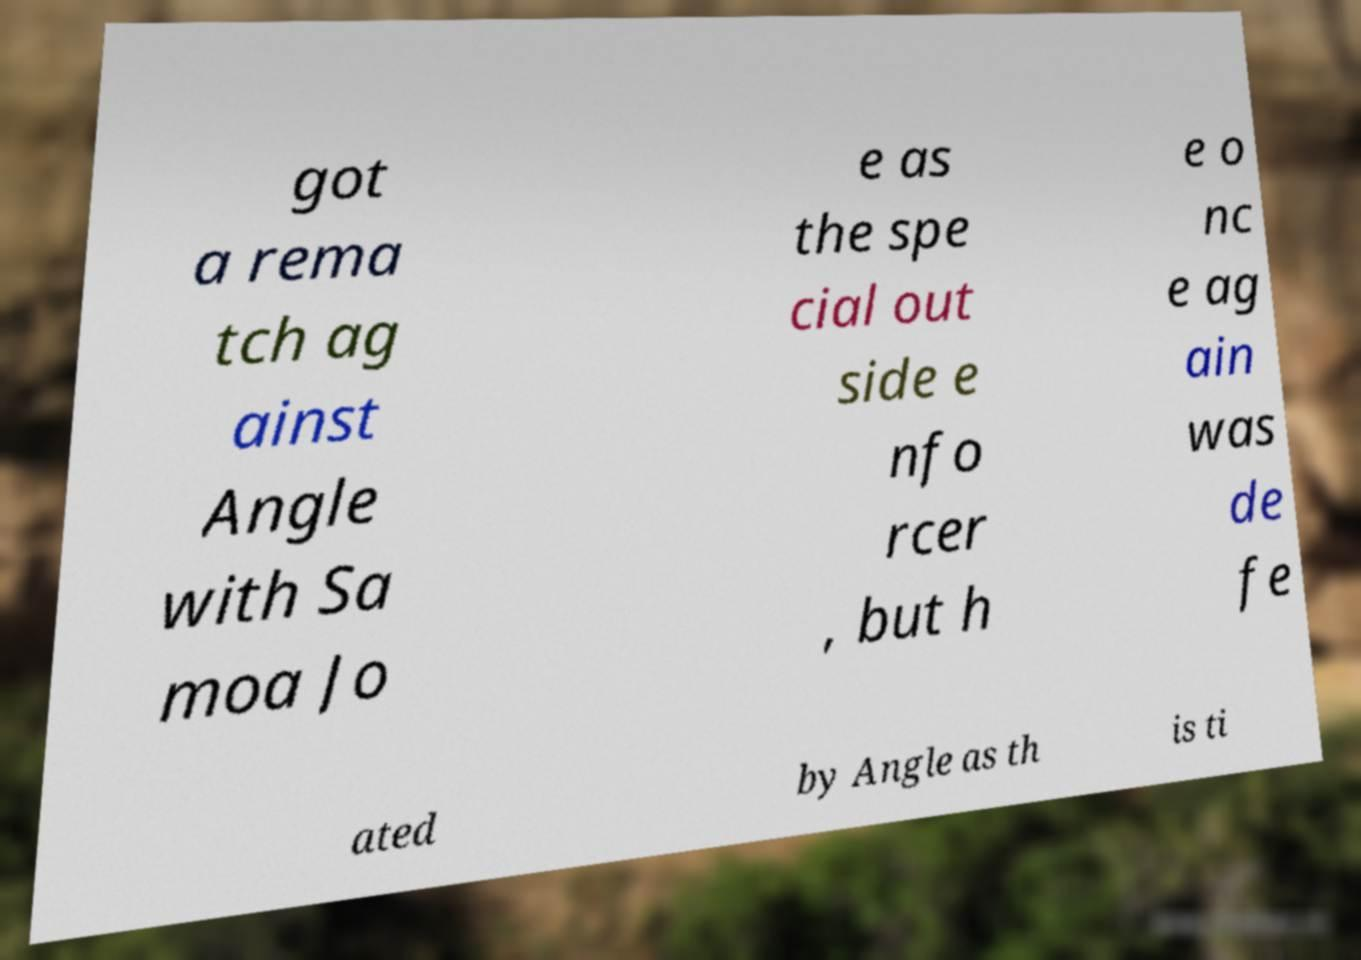Can you read and provide the text displayed in the image?This photo seems to have some interesting text. Can you extract and type it out for me? got a rema tch ag ainst Angle with Sa moa Jo e as the spe cial out side e nfo rcer , but h e o nc e ag ain was de fe ated by Angle as th is ti 